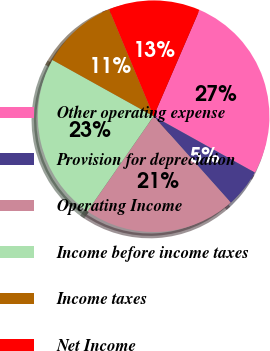<chart> <loc_0><loc_0><loc_500><loc_500><pie_chart><fcel>Other operating expense<fcel>Provision for depreciation<fcel>Operating Income<fcel>Income before income taxes<fcel>Income taxes<fcel>Net Income<nl><fcel>26.6%<fcel>5.32%<fcel>21.28%<fcel>23.4%<fcel>10.64%<fcel>12.77%<nl></chart> 